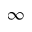Convert formula to latex. <formula><loc_0><loc_0><loc_500><loc_500>\infty</formula> 